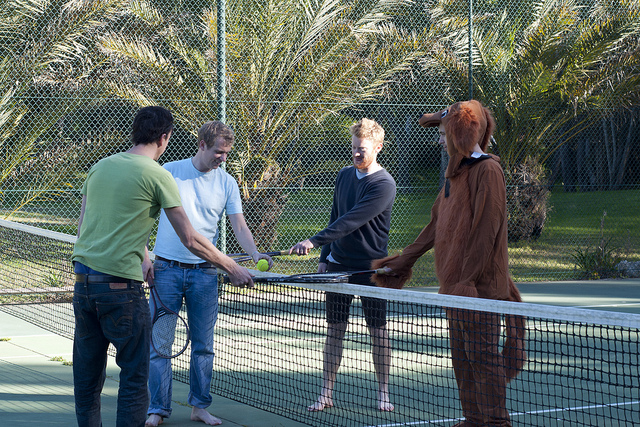Please provide the bounding box coordinate of the region this sentence describes: long sleeve shirt. [0.45, 0.35, 0.62, 0.81] 